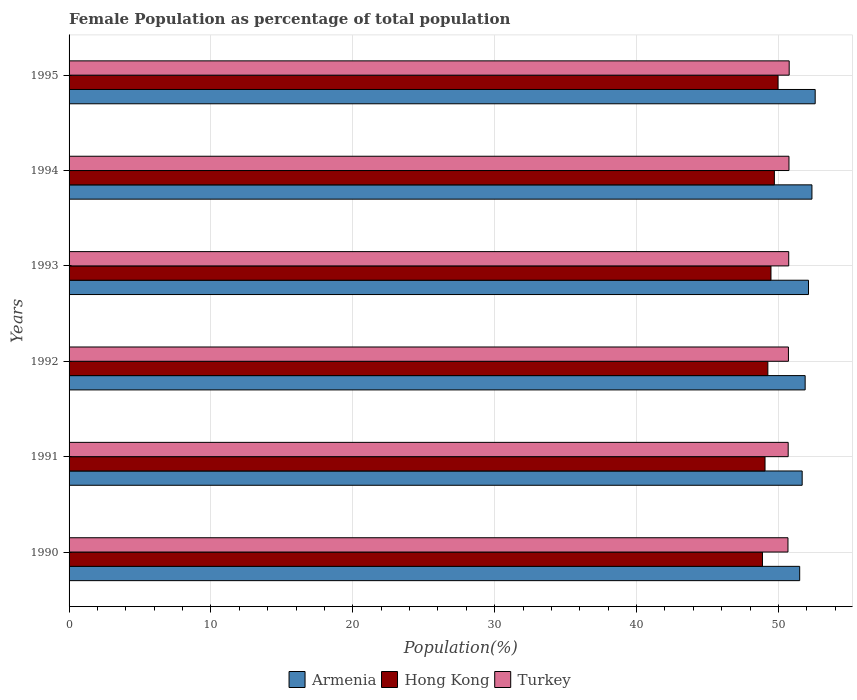How many bars are there on the 3rd tick from the top?
Offer a very short reply. 3. How many bars are there on the 4th tick from the bottom?
Make the answer very short. 3. What is the label of the 3rd group of bars from the top?
Ensure brevity in your answer.  1993. What is the female population in in Armenia in 1991?
Provide a short and direct response. 51.67. Across all years, what is the maximum female population in in Hong Kong?
Give a very brief answer. 49.97. Across all years, what is the minimum female population in in Hong Kong?
Offer a terse response. 48.87. What is the total female population in in Hong Kong in the graph?
Provide a short and direct response. 296.32. What is the difference between the female population in in Armenia in 1991 and that in 1992?
Your answer should be compact. -0.21. What is the difference between the female population in in Turkey in 1990 and the female population in in Hong Kong in 1991?
Give a very brief answer. 1.62. What is the average female population in in Armenia per year?
Make the answer very short. 52.02. In the year 1993, what is the difference between the female population in in Hong Kong and female population in in Armenia?
Ensure brevity in your answer.  -2.64. In how many years, is the female population in in Hong Kong greater than 16 %?
Your answer should be very brief. 6. What is the ratio of the female population in in Hong Kong in 1994 to that in 1995?
Your answer should be compact. 0.99. Is the female population in in Turkey in 1990 less than that in 1994?
Ensure brevity in your answer.  Yes. Is the difference between the female population in in Hong Kong in 1990 and 1993 greater than the difference between the female population in in Armenia in 1990 and 1993?
Offer a very short reply. Yes. What is the difference between the highest and the second highest female population in in Turkey?
Your answer should be compact. 0.02. What is the difference between the highest and the lowest female population in in Armenia?
Your answer should be compact. 1.09. In how many years, is the female population in in Turkey greater than the average female population in in Turkey taken over all years?
Your answer should be compact. 3. Are all the bars in the graph horizontal?
Your answer should be compact. Yes. How many years are there in the graph?
Your answer should be very brief. 6. Does the graph contain grids?
Provide a short and direct response. Yes. How are the legend labels stacked?
Your answer should be very brief. Horizontal. What is the title of the graph?
Your response must be concise. Female Population as percentage of total population. What is the label or title of the X-axis?
Give a very brief answer. Population(%). What is the Population(%) in Armenia in 1990?
Your answer should be compact. 51.49. What is the Population(%) in Hong Kong in 1990?
Offer a very short reply. 48.87. What is the Population(%) in Turkey in 1990?
Your answer should be very brief. 50.67. What is the Population(%) in Armenia in 1991?
Your response must be concise. 51.67. What is the Population(%) in Hong Kong in 1991?
Provide a succinct answer. 49.05. What is the Population(%) in Turkey in 1991?
Your answer should be compact. 50.68. What is the Population(%) of Armenia in 1992?
Make the answer very short. 51.88. What is the Population(%) of Hong Kong in 1992?
Ensure brevity in your answer.  49.25. What is the Population(%) of Turkey in 1992?
Offer a terse response. 50.7. What is the Population(%) in Armenia in 1993?
Keep it short and to the point. 52.11. What is the Population(%) of Hong Kong in 1993?
Your answer should be compact. 49.47. What is the Population(%) in Turkey in 1993?
Offer a very short reply. 50.72. What is the Population(%) in Armenia in 1994?
Provide a short and direct response. 52.36. What is the Population(%) in Hong Kong in 1994?
Keep it short and to the point. 49.71. What is the Population(%) of Turkey in 1994?
Keep it short and to the point. 50.74. What is the Population(%) in Armenia in 1995?
Provide a short and direct response. 52.59. What is the Population(%) of Hong Kong in 1995?
Your answer should be compact. 49.97. What is the Population(%) in Turkey in 1995?
Your response must be concise. 50.75. Across all years, what is the maximum Population(%) of Armenia?
Offer a very short reply. 52.59. Across all years, what is the maximum Population(%) of Hong Kong?
Your answer should be compact. 49.97. Across all years, what is the maximum Population(%) of Turkey?
Offer a terse response. 50.75. Across all years, what is the minimum Population(%) in Armenia?
Make the answer very short. 51.49. Across all years, what is the minimum Population(%) of Hong Kong?
Offer a terse response. 48.87. Across all years, what is the minimum Population(%) of Turkey?
Provide a succinct answer. 50.67. What is the total Population(%) in Armenia in the graph?
Offer a very short reply. 312.1. What is the total Population(%) in Hong Kong in the graph?
Keep it short and to the point. 296.32. What is the total Population(%) in Turkey in the graph?
Provide a short and direct response. 304.26. What is the difference between the Population(%) in Armenia in 1990 and that in 1991?
Keep it short and to the point. -0.18. What is the difference between the Population(%) in Hong Kong in 1990 and that in 1991?
Your answer should be compact. -0.18. What is the difference between the Population(%) in Turkey in 1990 and that in 1991?
Your answer should be very brief. -0.02. What is the difference between the Population(%) in Armenia in 1990 and that in 1992?
Your response must be concise. -0.39. What is the difference between the Population(%) of Hong Kong in 1990 and that in 1992?
Your answer should be compact. -0.38. What is the difference between the Population(%) in Turkey in 1990 and that in 1992?
Your answer should be very brief. -0.03. What is the difference between the Population(%) of Armenia in 1990 and that in 1993?
Ensure brevity in your answer.  -0.62. What is the difference between the Population(%) of Hong Kong in 1990 and that in 1993?
Keep it short and to the point. -0.6. What is the difference between the Population(%) in Turkey in 1990 and that in 1993?
Your answer should be very brief. -0.05. What is the difference between the Population(%) in Armenia in 1990 and that in 1994?
Keep it short and to the point. -0.86. What is the difference between the Population(%) of Hong Kong in 1990 and that in 1994?
Provide a short and direct response. -0.84. What is the difference between the Population(%) of Turkey in 1990 and that in 1994?
Provide a short and direct response. -0.07. What is the difference between the Population(%) of Armenia in 1990 and that in 1995?
Offer a terse response. -1.09. What is the difference between the Population(%) in Hong Kong in 1990 and that in 1995?
Give a very brief answer. -1.1. What is the difference between the Population(%) of Turkey in 1990 and that in 1995?
Ensure brevity in your answer.  -0.09. What is the difference between the Population(%) of Armenia in 1991 and that in 1992?
Your answer should be compact. -0.21. What is the difference between the Population(%) of Hong Kong in 1991 and that in 1992?
Offer a terse response. -0.2. What is the difference between the Population(%) in Turkey in 1991 and that in 1992?
Make the answer very short. -0.02. What is the difference between the Population(%) in Armenia in 1991 and that in 1993?
Keep it short and to the point. -0.45. What is the difference between the Population(%) in Hong Kong in 1991 and that in 1993?
Ensure brevity in your answer.  -0.42. What is the difference between the Population(%) of Turkey in 1991 and that in 1993?
Your answer should be very brief. -0.04. What is the difference between the Population(%) in Armenia in 1991 and that in 1994?
Your answer should be very brief. -0.69. What is the difference between the Population(%) in Hong Kong in 1991 and that in 1994?
Make the answer very short. -0.66. What is the difference between the Population(%) of Turkey in 1991 and that in 1994?
Offer a terse response. -0.06. What is the difference between the Population(%) in Armenia in 1991 and that in 1995?
Offer a very short reply. -0.92. What is the difference between the Population(%) in Hong Kong in 1991 and that in 1995?
Offer a very short reply. -0.92. What is the difference between the Population(%) in Turkey in 1991 and that in 1995?
Your response must be concise. -0.07. What is the difference between the Population(%) in Armenia in 1992 and that in 1993?
Make the answer very short. -0.24. What is the difference between the Population(%) of Hong Kong in 1992 and that in 1993?
Your answer should be very brief. -0.22. What is the difference between the Population(%) of Turkey in 1992 and that in 1993?
Your answer should be compact. -0.02. What is the difference between the Population(%) of Armenia in 1992 and that in 1994?
Keep it short and to the point. -0.48. What is the difference between the Population(%) in Hong Kong in 1992 and that in 1994?
Offer a terse response. -0.46. What is the difference between the Population(%) in Turkey in 1992 and that in 1994?
Offer a very short reply. -0.04. What is the difference between the Population(%) of Armenia in 1992 and that in 1995?
Offer a very short reply. -0.71. What is the difference between the Population(%) of Hong Kong in 1992 and that in 1995?
Ensure brevity in your answer.  -0.72. What is the difference between the Population(%) of Turkey in 1992 and that in 1995?
Offer a very short reply. -0.05. What is the difference between the Population(%) in Armenia in 1993 and that in 1994?
Give a very brief answer. -0.24. What is the difference between the Population(%) in Hong Kong in 1993 and that in 1994?
Your answer should be compact. -0.24. What is the difference between the Population(%) of Turkey in 1993 and that in 1994?
Your answer should be compact. -0.02. What is the difference between the Population(%) in Armenia in 1993 and that in 1995?
Give a very brief answer. -0.47. What is the difference between the Population(%) of Hong Kong in 1993 and that in 1995?
Your answer should be very brief. -0.5. What is the difference between the Population(%) in Turkey in 1993 and that in 1995?
Your answer should be compact. -0.03. What is the difference between the Population(%) in Armenia in 1994 and that in 1995?
Provide a short and direct response. -0.23. What is the difference between the Population(%) in Hong Kong in 1994 and that in 1995?
Keep it short and to the point. -0.26. What is the difference between the Population(%) in Turkey in 1994 and that in 1995?
Your answer should be very brief. -0.02. What is the difference between the Population(%) of Armenia in 1990 and the Population(%) of Hong Kong in 1991?
Make the answer very short. 2.44. What is the difference between the Population(%) of Armenia in 1990 and the Population(%) of Turkey in 1991?
Your answer should be compact. 0.81. What is the difference between the Population(%) in Hong Kong in 1990 and the Population(%) in Turkey in 1991?
Provide a succinct answer. -1.81. What is the difference between the Population(%) in Armenia in 1990 and the Population(%) in Hong Kong in 1992?
Give a very brief answer. 2.24. What is the difference between the Population(%) in Armenia in 1990 and the Population(%) in Turkey in 1992?
Your answer should be compact. 0.79. What is the difference between the Population(%) in Hong Kong in 1990 and the Population(%) in Turkey in 1992?
Make the answer very short. -1.83. What is the difference between the Population(%) in Armenia in 1990 and the Population(%) in Hong Kong in 1993?
Your response must be concise. 2.02. What is the difference between the Population(%) of Armenia in 1990 and the Population(%) of Turkey in 1993?
Offer a very short reply. 0.77. What is the difference between the Population(%) in Hong Kong in 1990 and the Population(%) in Turkey in 1993?
Provide a succinct answer. -1.85. What is the difference between the Population(%) of Armenia in 1990 and the Population(%) of Hong Kong in 1994?
Offer a terse response. 1.78. What is the difference between the Population(%) of Armenia in 1990 and the Population(%) of Turkey in 1994?
Provide a short and direct response. 0.76. What is the difference between the Population(%) in Hong Kong in 1990 and the Population(%) in Turkey in 1994?
Keep it short and to the point. -1.87. What is the difference between the Population(%) of Armenia in 1990 and the Population(%) of Hong Kong in 1995?
Give a very brief answer. 1.53. What is the difference between the Population(%) in Armenia in 1990 and the Population(%) in Turkey in 1995?
Your answer should be compact. 0.74. What is the difference between the Population(%) of Hong Kong in 1990 and the Population(%) of Turkey in 1995?
Keep it short and to the point. -1.88. What is the difference between the Population(%) of Armenia in 1991 and the Population(%) of Hong Kong in 1992?
Your response must be concise. 2.42. What is the difference between the Population(%) of Hong Kong in 1991 and the Population(%) of Turkey in 1992?
Offer a very short reply. -1.65. What is the difference between the Population(%) of Armenia in 1991 and the Population(%) of Hong Kong in 1993?
Your response must be concise. 2.2. What is the difference between the Population(%) in Armenia in 1991 and the Population(%) in Turkey in 1993?
Ensure brevity in your answer.  0.95. What is the difference between the Population(%) in Hong Kong in 1991 and the Population(%) in Turkey in 1993?
Offer a terse response. -1.67. What is the difference between the Population(%) in Armenia in 1991 and the Population(%) in Hong Kong in 1994?
Give a very brief answer. 1.96. What is the difference between the Population(%) of Armenia in 1991 and the Population(%) of Turkey in 1994?
Make the answer very short. 0.93. What is the difference between the Population(%) of Hong Kong in 1991 and the Population(%) of Turkey in 1994?
Your answer should be very brief. -1.69. What is the difference between the Population(%) of Armenia in 1991 and the Population(%) of Hong Kong in 1995?
Offer a very short reply. 1.7. What is the difference between the Population(%) of Armenia in 1991 and the Population(%) of Turkey in 1995?
Provide a short and direct response. 0.92. What is the difference between the Population(%) in Hong Kong in 1991 and the Population(%) in Turkey in 1995?
Give a very brief answer. -1.7. What is the difference between the Population(%) in Armenia in 1992 and the Population(%) in Hong Kong in 1993?
Offer a very short reply. 2.41. What is the difference between the Population(%) in Armenia in 1992 and the Population(%) in Turkey in 1993?
Give a very brief answer. 1.16. What is the difference between the Population(%) of Hong Kong in 1992 and the Population(%) of Turkey in 1993?
Your response must be concise. -1.47. What is the difference between the Population(%) of Armenia in 1992 and the Population(%) of Hong Kong in 1994?
Keep it short and to the point. 2.17. What is the difference between the Population(%) in Armenia in 1992 and the Population(%) in Turkey in 1994?
Provide a short and direct response. 1.14. What is the difference between the Population(%) in Hong Kong in 1992 and the Population(%) in Turkey in 1994?
Make the answer very short. -1.49. What is the difference between the Population(%) in Armenia in 1992 and the Population(%) in Hong Kong in 1995?
Offer a very short reply. 1.91. What is the difference between the Population(%) in Armenia in 1992 and the Population(%) in Turkey in 1995?
Provide a short and direct response. 1.13. What is the difference between the Population(%) of Hong Kong in 1992 and the Population(%) of Turkey in 1995?
Offer a terse response. -1.5. What is the difference between the Population(%) in Armenia in 1993 and the Population(%) in Hong Kong in 1994?
Ensure brevity in your answer.  2.4. What is the difference between the Population(%) of Armenia in 1993 and the Population(%) of Turkey in 1994?
Give a very brief answer. 1.38. What is the difference between the Population(%) of Hong Kong in 1993 and the Population(%) of Turkey in 1994?
Give a very brief answer. -1.27. What is the difference between the Population(%) of Armenia in 1993 and the Population(%) of Hong Kong in 1995?
Your response must be concise. 2.15. What is the difference between the Population(%) in Armenia in 1993 and the Population(%) in Turkey in 1995?
Your answer should be very brief. 1.36. What is the difference between the Population(%) of Hong Kong in 1993 and the Population(%) of Turkey in 1995?
Offer a very short reply. -1.28. What is the difference between the Population(%) of Armenia in 1994 and the Population(%) of Hong Kong in 1995?
Keep it short and to the point. 2.39. What is the difference between the Population(%) in Armenia in 1994 and the Population(%) in Turkey in 1995?
Keep it short and to the point. 1.6. What is the difference between the Population(%) of Hong Kong in 1994 and the Population(%) of Turkey in 1995?
Keep it short and to the point. -1.04. What is the average Population(%) in Armenia per year?
Provide a succinct answer. 52.02. What is the average Population(%) in Hong Kong per year?
Your answer should be compact. 49.39. What is the average Population(%) in Turkey per year?
Give a very brief answer. 50.71. In the year 1990, what is the difference between the Population(%) of Armenia and Population(%) of Hong Kong?
Offer a very short reply. 2.62. In the year 1990, what is the difference between the Population(%) of Armenia and Population(%) of Turkey?
Provide a succinct answer. 0.83. In the year 1990, what is the difference between the Population(%) of Hong Kong and Population(%) of Turkey?
Ensure brevity in your answer.  -1.8. In the year 1991, what is the difference between the Population(%) in Armenia and Population(%) in Hong Kong?
Offer a very short reply. 2.62. In the year 1991, what is the difference between the Population(%) in Armenia and Population(%) in Turkey?
Make the answer very short. 0.99. In the year 1991, what is the difference between the Population(%) of Hong Kong and Population(%) of Turkey?
Your answer should be very brief. -1.63. In the year 1992, what is the difference between the Population(%) in Armenia and Population(%) in Hong Kong?
Offer a terse response. 2.63. In the year 1992, what is the difference between the Population(%) in Armenia and Population(%) in Turkey?
Provide a short and direct response. 1.18. In the year 1992, what is the difference between the Population(%) in Hong Kong and Population(%) in Turkey?
Offer a terse response. -1.45. In the year 1993, what is the difference between the Population(%) of Armenia and Population(%) of Hong Kong?
Give a very brief answer. 2.64. In the year 1993, what is the difference between the Population(%) of Armenia and Population(%) of Turkey?
Offer a terse response. 1.39. In the year 1993, what is the difference between the Population(%) in Hong Kong and Population(%) in Turkey?
Provide a succinct answer. -1.25. In the year 1994, what is the difference between the Population(%) in Armenia and Population(%) in Hong Kong?
Provide a short and direct response. 2.65. In the year 1994, what is the difference between the Population(%) in Armenia and Population(%) in Turkey?
Make the answer very short. 1.62. In the year 1994, what is the difference between the Population(%) of Hong Kong and Population(%) of Turkey?
Offer a very short reply. -1.03. In the year 1995, what is the difference between the Population(%) in Armenia and Population(%) in Hong Kong?
Make the answer very short. 2.62. In the year 1995, what is the difference between the Population(%) in Armenia and Population(%) in Turkey?
Offer a terse response. 1.83. In the year 1995, what is the difference between the Population(%) in Hong Kong and Population(%) in Turkey?
Your response must be concise. -0.79. What is the ratio of the Population(%) in Armenia in 1990 to that in 1992?
Keep it short and to the point. 0.99. What is the ratio of the Population(%) in Armenia in 1990 to that in 1993?
Provide a succinct answer. 0.99. What is the ratio of the Population(%) in Hong Kong in 1990 to that in 1993?
Your response must be concise. 0.99. What is the ratio of the Population(%) of Armenia in 1990 to that in 1994?
Provide a succinct answer. 0.98. What is the ratio of the Population(%) of Hong Kong in 1990 to that in 1994?
Ensure brevity in your answer.  0.98. What is the ratio of the Population(%) of Turkey in 1990 to that in 1994?
Ensure brevity in your answer.  1. What is the ratio of the Population(%) of Armenia in 1990 to that in 1995?
Your answer should be very brief. 0.98. What is the ratio of the Population(%) in Turkey in 1990 to that in 1995?
Your answer should be very brief. 1. What is the ratio of the Population(%) of Hong Kong in 1991 to that in 1992?
Provide a succinct answer. 1. What is the ratio of the Population(%) in Armenia in 1991 to that in 1993?
Ensure brevity in your answer.  0.99. What is the ratio of the Population(%) of Turkey in 1991 to that in 1993?
Give a very brief answer. 1. What is the ratio of the Population(%) of Armenia in 1991 to that in 1994?
Offer a very short reply. 0.99. What is the ratio of the Population(%) in Hong Kong in 1991 to that in 1994?
Your answer should be very brief. 0.99. What is the ratio of the Population(%) of Armenia in 1991 to that in 1995?
Offer a terse response. 0.98. What is the ratio of the Population(%) of Hong Kong in 1991 to that in 1995?
Your response must be concise. 0.98. What is the ratio of the Population(%) of Turkey in 1991 to that in 1995?
Ensure brevity in your answer.  1. What is the ratio of the Population(%) of Armenia in 1992 to that in 1994?
Give a very brief answer. 0.99. What is the ratio of the Population(%) in Armenia in 1992 to that in 1995?
Offer a very short reply. 0.99. What is the ratio of the Population(%) in Hong Kong in 1992 to that in 1995?
Offer a terse response. 0.99. What is the ratio of the Population(%) of Turkey in 1993 to that in 1994?
Ensure brevity in your answer.  1. What is the ratio of the Population(%) of Hong Kong in 1993 to that in 1995?
Your answer should be very brief. 0.99. What is the ratio of the Population(%) of Armenia in 1994 to that in 1995?
Ensure brevity in your answer.  1. What is the ratio of the Population(%) of Turkey in 1994 to that in 1995?
Your answer should be compact. 1. What is the difference between the highest and the second highest Population(%) of Armenia?
Keep it short and to the point. 0.23. What is the difference between the highest and the second highest Population(%) in Hong Kong?
Your response must be concise. 0.26. What is the difference between the highest and the second highest Population(%) in Turkey?
Provide a succinct answer. 0.02. What is the difference between the highest and the lowest Population(%) in Armenia?
Give a very brief answer. 1.09. What is the difference between the highest and the lowest Population(%) in Hong Kong?
Ensure brevity in your answer.  1.1. What is the difference between the highest and the lowest Population(%) of Turkey?
Provide a succinct answer. 0.09. 